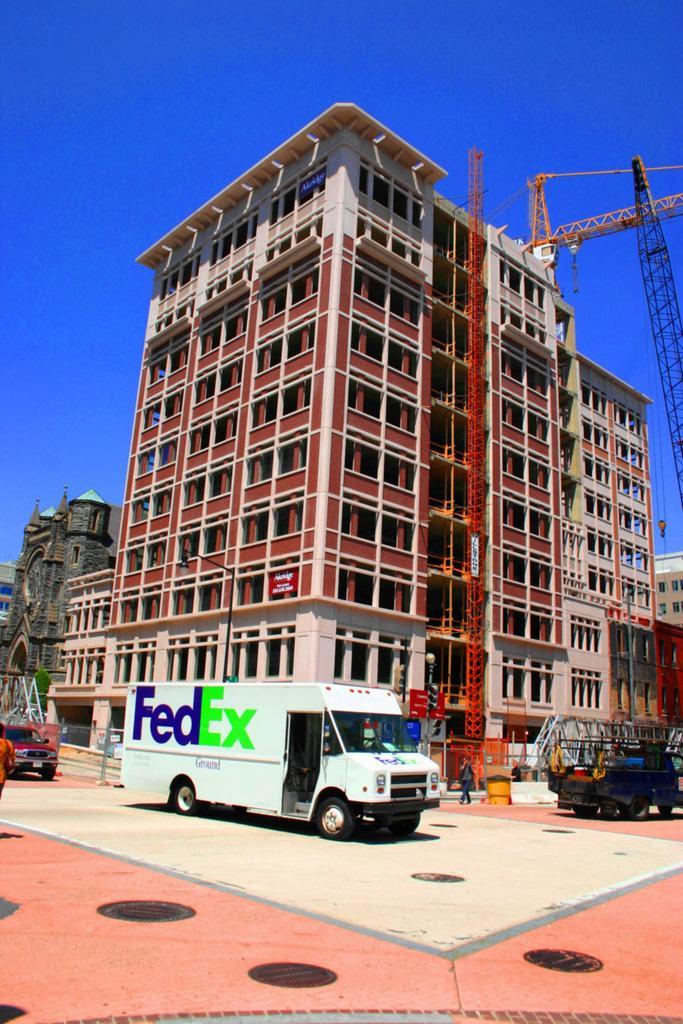Describe this image in one or two sentences. In this image there is a building in the middle. At the top there is the sky. At the bottom there is a truck in the middle. On the right side there is a crane. On the left side there are few other buildings. On the floor there is a person who is walking on it. In front of him there is a car. 